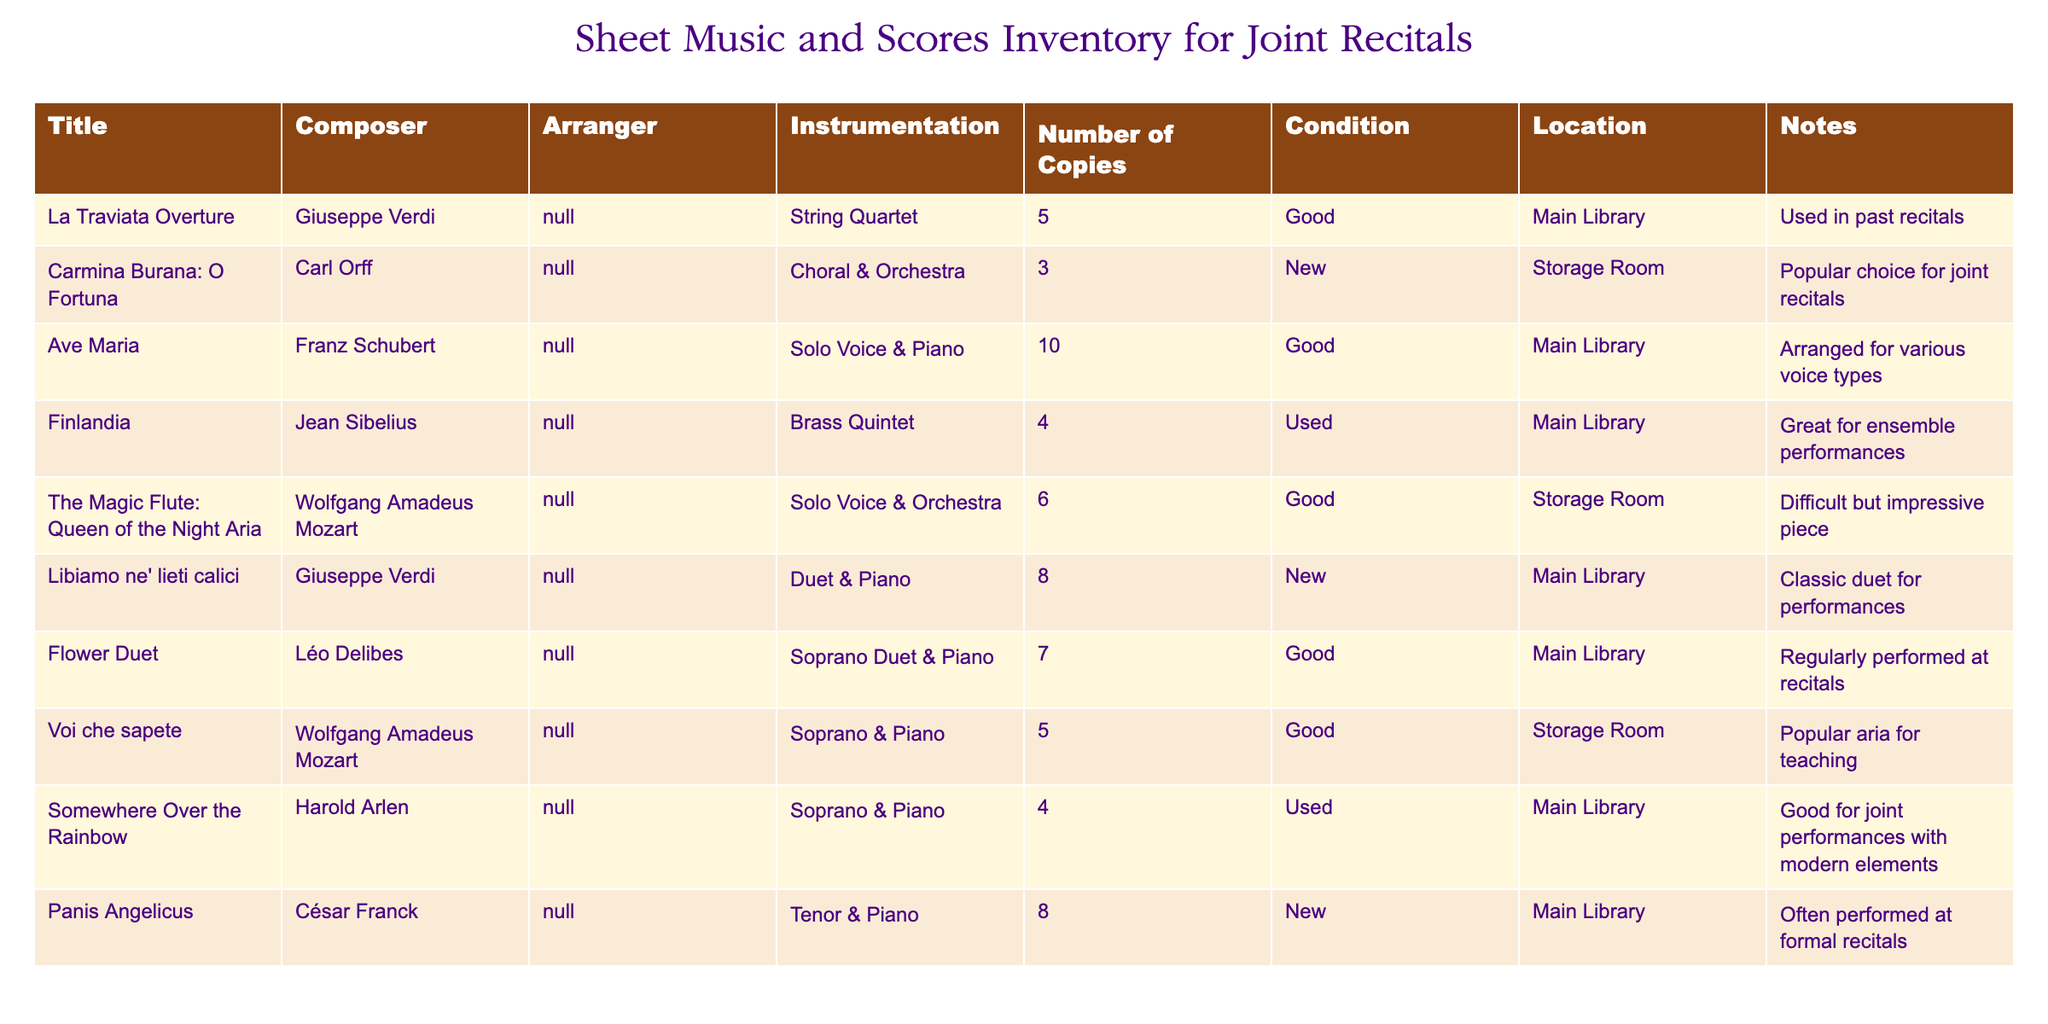What is the total number of copies of "Ave Maria"? The table shows that there are 10 copies of "Ave Maria." You can find this information directly in the "Number of Copies" column next to the title "Ave Maria."
Answer: 10 How many pieces of sheet music are in "New" condition? By examining the "Condition" column, we see that there are three pieces in "New" condition: "Carmina Burana: O Fortuna," "Libiamo ne' lieti calici," and "Panis Angelicus." Thus, the total is 3.
Answer: 3 Is "Somewhere Over the Rainbow" located in Storage Room? The table lists "Somewhere Over the Rainbow" and indicates its location as "Main Library," not "Storage Room." Therefore, the statement is false.
Answer: No Which piece has the most number of copies? Looking through the "Number of Copies" column, "Ave Maria" has the highest number at 10 copies compared to others.
Answer: Ave Maria What is the average number of copies for pieces classified as "Good" condition? We identify the pieces in "Good" condition: "La Traviata Overture" (5), "Ave Maria" (10), "Finlandia" (4), "Flower Duet" (7), "Voi che sapete" (5), and "The Magic Flute: Queen of the Night Aria" (6). The sum of these values is 37 and there are 6 pieces, so the average is 37/6 = 6.17.
Answer: 6.17 How many pieces can be classified for Solo Voice? The table shows "Ave Maria," "The Magic Flute: Queen of the Night Aria," and "Somewhere Over the Rainbow" as pieces for Solo Voice. Hence, there are 3 such pieces.
Answer: 3 Is "Finlandia" used for ensemble performances? The notes for "Finlandia" state that it is "Great for ensemble performances," confirming that this statement is true.
Answer: Yes Which composer has the most works listed in the inventory? By reviewing the "Composer" column, we see works by Verdi (2), Mozart (2), Orff (1), Schubert (1), Sibelius (1), Delibes (1), Franck (1), and Arlen (1). Thus, Verdi and Mozart tie for the most with 2 works each.
Answer: Verdi and Mozart 